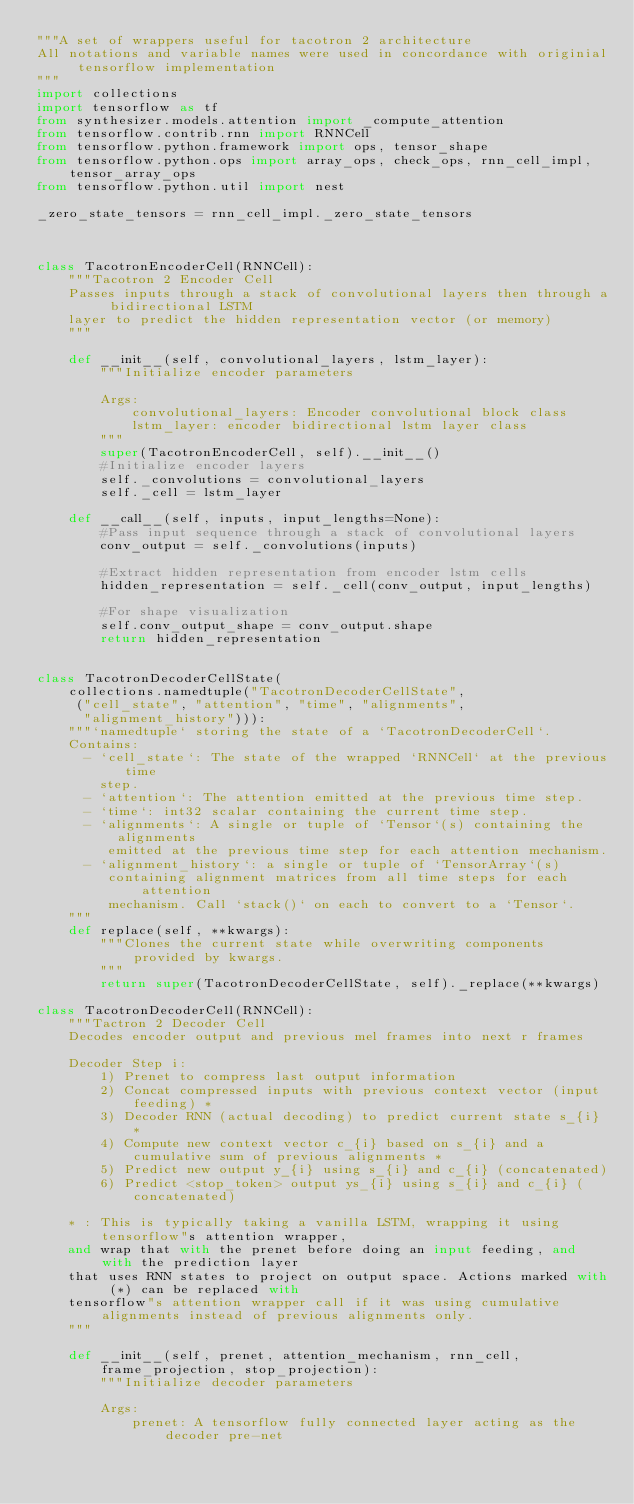Convert code to text. <code><loc_0><loc_0><loc_500><loc_500><_Python_>"""A set of wrappers useful for tacotron 2 architecture
All notations and variable names were used in concordance with originial tensorflow implementation
"""
import collections
import tensorflow as tf
from synthesizer.models.attention import _compute_attention
from tensorflow.contrib.rnn import RNNCell
from tensorflow.python.framework import ops, tensor_shape
from tensorflow.python.ops import array_ops, check_ops, rnn_cell_impl, tensor_array_ops
from tensorflow.python.util import nest

_zero_state_tensors = rnn_cell_impl._zero_state_tensors



class TacotronEncoderCell(RNNCell):
    """Tacotron 2 Encoder Cell
    Passes inputs through a stack of convolutional layers then through a bidirectional LSTM
    layer to predict the hidden representation vector (or memory)
    """

    def __init__(self, convolutional_layers, lstm_layer):
        """Initialize encoder parameters

        Args:
            convolutional_layers: Encoder convolutional block class
            lstm_layer: encoder bidirectional lstm layer class
        """
        super(TacotronEncoderCell, self).__init__()
        #Initialize encoder layers
        self._convolutions = convolutional_layers
        self._cell = lstm_layer

    def __call__(self, inputs, input_lengths=None):
        #Pass input sequence through a stack of convolutional layers
        conv_output = self._convolutions(inputs)

        #Extract hidden representation from encoder lstm cells
        hidden_representation = self._cell(conv_output, input_lengths)

        #For shape visualization
        self.conv_output_shape = conv_output.shape
        return hidden_representation


class TacotronDecoderCellState(
    collections.namedtuple("TacotronDecoderCellState",
     ("cell_state", "attention", "time", "alignments",
      "alignment_history"))):
    """`namedtuple` storing the state of a `TacotronDecoderCell`.
    Contains:
      - `cell_state`: The state of the wrapped `RNNCell` at the previous time
        step.
      - `attention`: The attention emitted at the previous time step.
      - `time`: int32 scalar containing the current time step.
      - `alignments`: A single or tuple of `Tensor`(s) containing the alignments
         emitted at the previous time step for each attention mechanism.
      - `alignment_history`: a single or tuple of `TensorArray`(s)
         containing alignment matrices from all time steps for each attention
         mechanism. Call `stack()` on each to convert to a `Tensor`.
    """
    def replace(self, **kwargs):
        """Clones the current state while overwriting components provided by kwargs.
        """
        return super(TacotronDecoderCellState, self)._replace(**kwargs)

class TacotronDecoderCell(RNNCell):
    """Tactron 2 Decoder Cell
    Decodes encoder output and previous mel frames into next r frames

    Decoder Step i:
        1) Prenet to compress last output information
        2) Concat compressed inputs with previous context vector (input feeding) *
        3) Decoder RNN (actual decoding) to predict current state s_{i} *
        4) Compute new context vector c_{i} based on s_{i} and a cumulative sum of previous alignments *
        5) Predict new output y_{i} using s_{i} and c_{i} (concatenated)
        6) Predict <stop_token> output ys_{i} using s_{i} and c_{i} (concatenated)

    * : This is typically taking a vanilla LSTM, wrapping it using tensorflow"s attention wrapper,
    and wrap that with the prenet before doing an input feeding, and with the prediction layer
    that uses RNN states to project on output space. Actions marked with (*) can be replaced with
    tensorflow"s attention wrapper call if it was using cumulative alignments instead of previous alignments only.
    """

    def __init__(self, prenet, attention_mechanism, rnn_cell, frame_projection, stop_projection):
        """Initialize decoder parameters

        Args:
            prenet: A tensorflow fully connected layer acting as the decoder pre-net</code> 